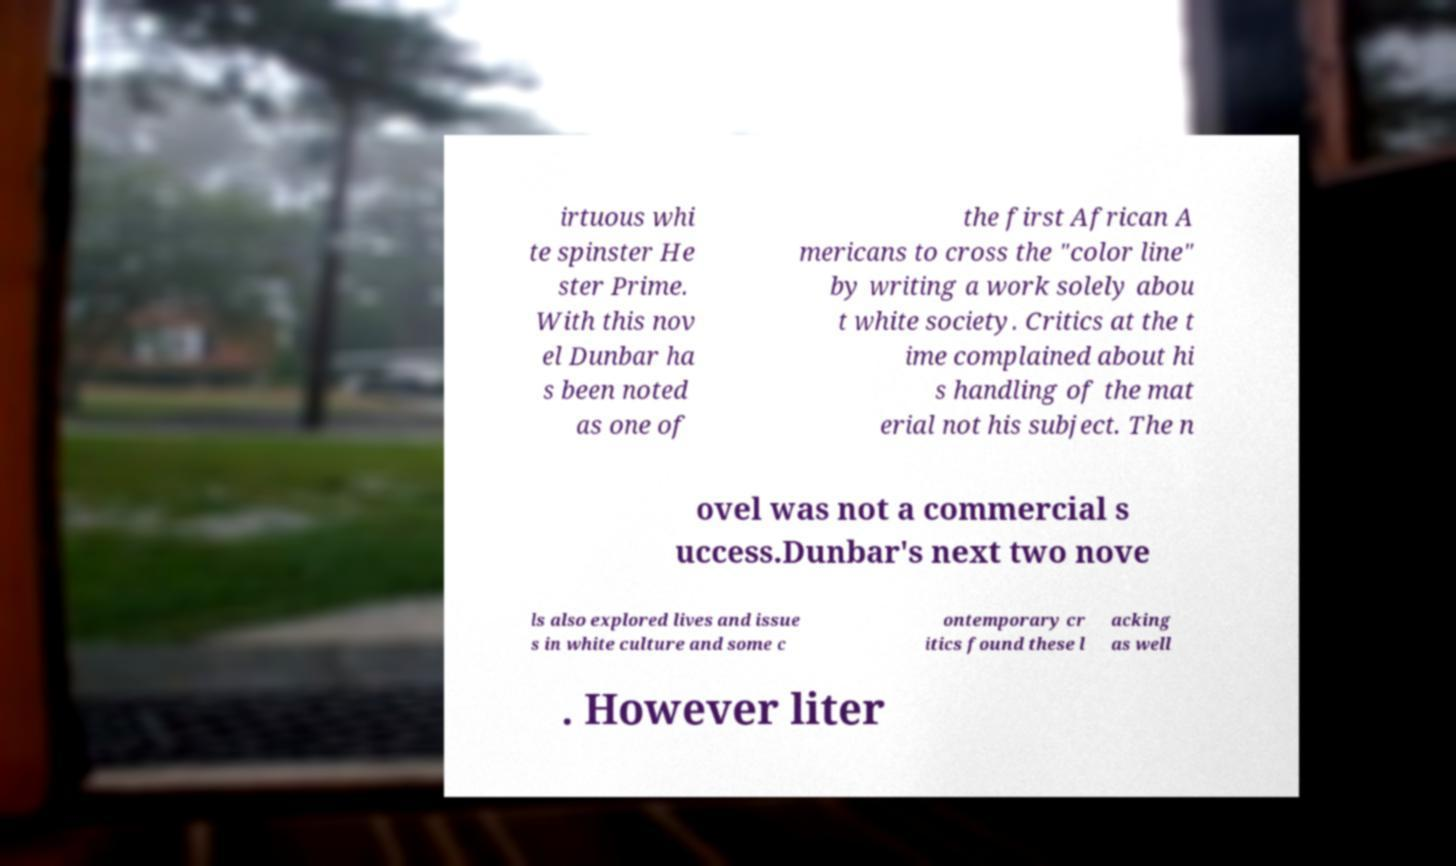Can you read and provide the text displayed in the image?This photo seems to have some interesting text. Can you extract and type it out for me? irtuous whi te spinster He ster Prime. With this nov el Dunbar ha s been noted as one of the first African A mericans to cross the "color line" by writing a work solely abou t white society. Critics at the t ime complained about hi s handling of the mat erial not his subject. The n ovel was not a commercial s uccess.Dunbar's next two nove ls also explored lives and issue s in white culture and some c ontemporary cr itics found these l acking as well . However liter 